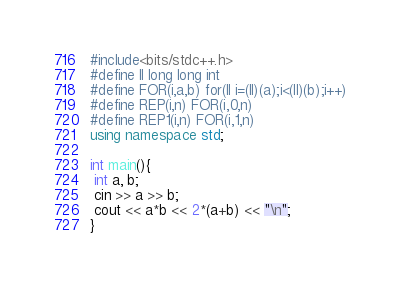<code> <loc_0><loc_0><loc_500><loc_500><_C++_>#include<bits/stdc++.h>
#define ll long long int
#define FOR(i,a,b) for(ll i=(ll)(a);i<(ll)(b);i++)
#define REP(i,n) FOR(i,0,n)
#define REP1(i,n) FOR(i,1,n)
using namespace std;

int main(){
 int a, b;
 cin >> a >> b;
 cout << a*b << 2*(a+b) << "\n";
}</code> 